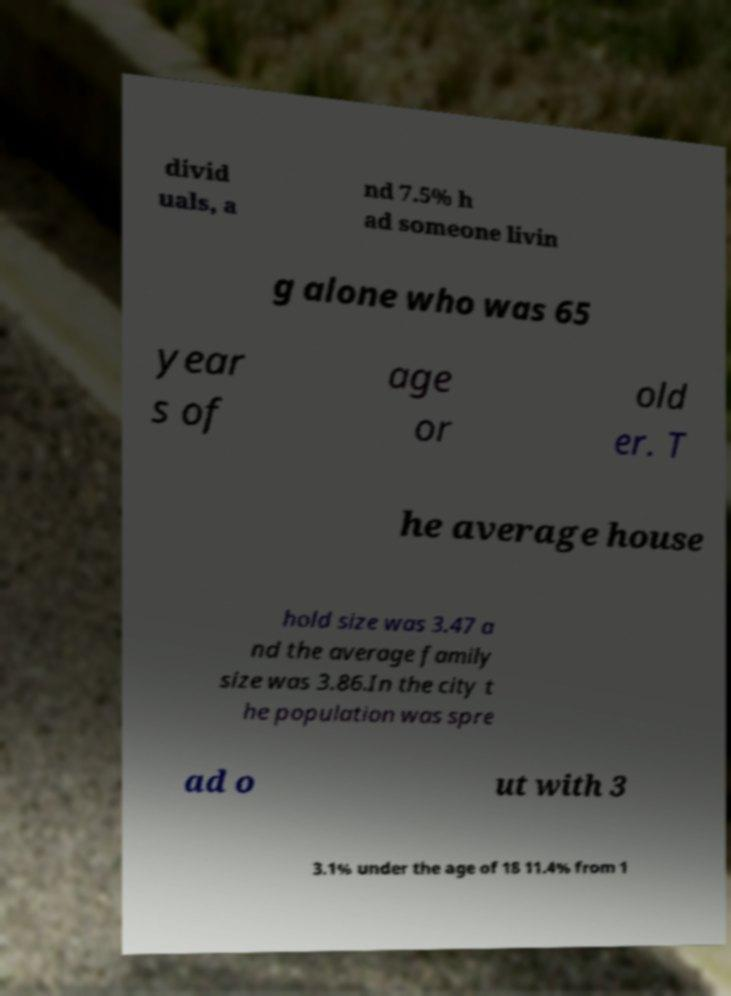There's text embedded in this image that I need extracted. Can you transcribe it verbatim? divid uals, a nd 7.5% h ad someone livin g alone who was 65 year s of age or old er. T he average house hold size was 3.47 a nd the average family size was 3.86.In the city t he population was spre ad o ut with 3 3.1% under the age of 18 11.4% from 1 